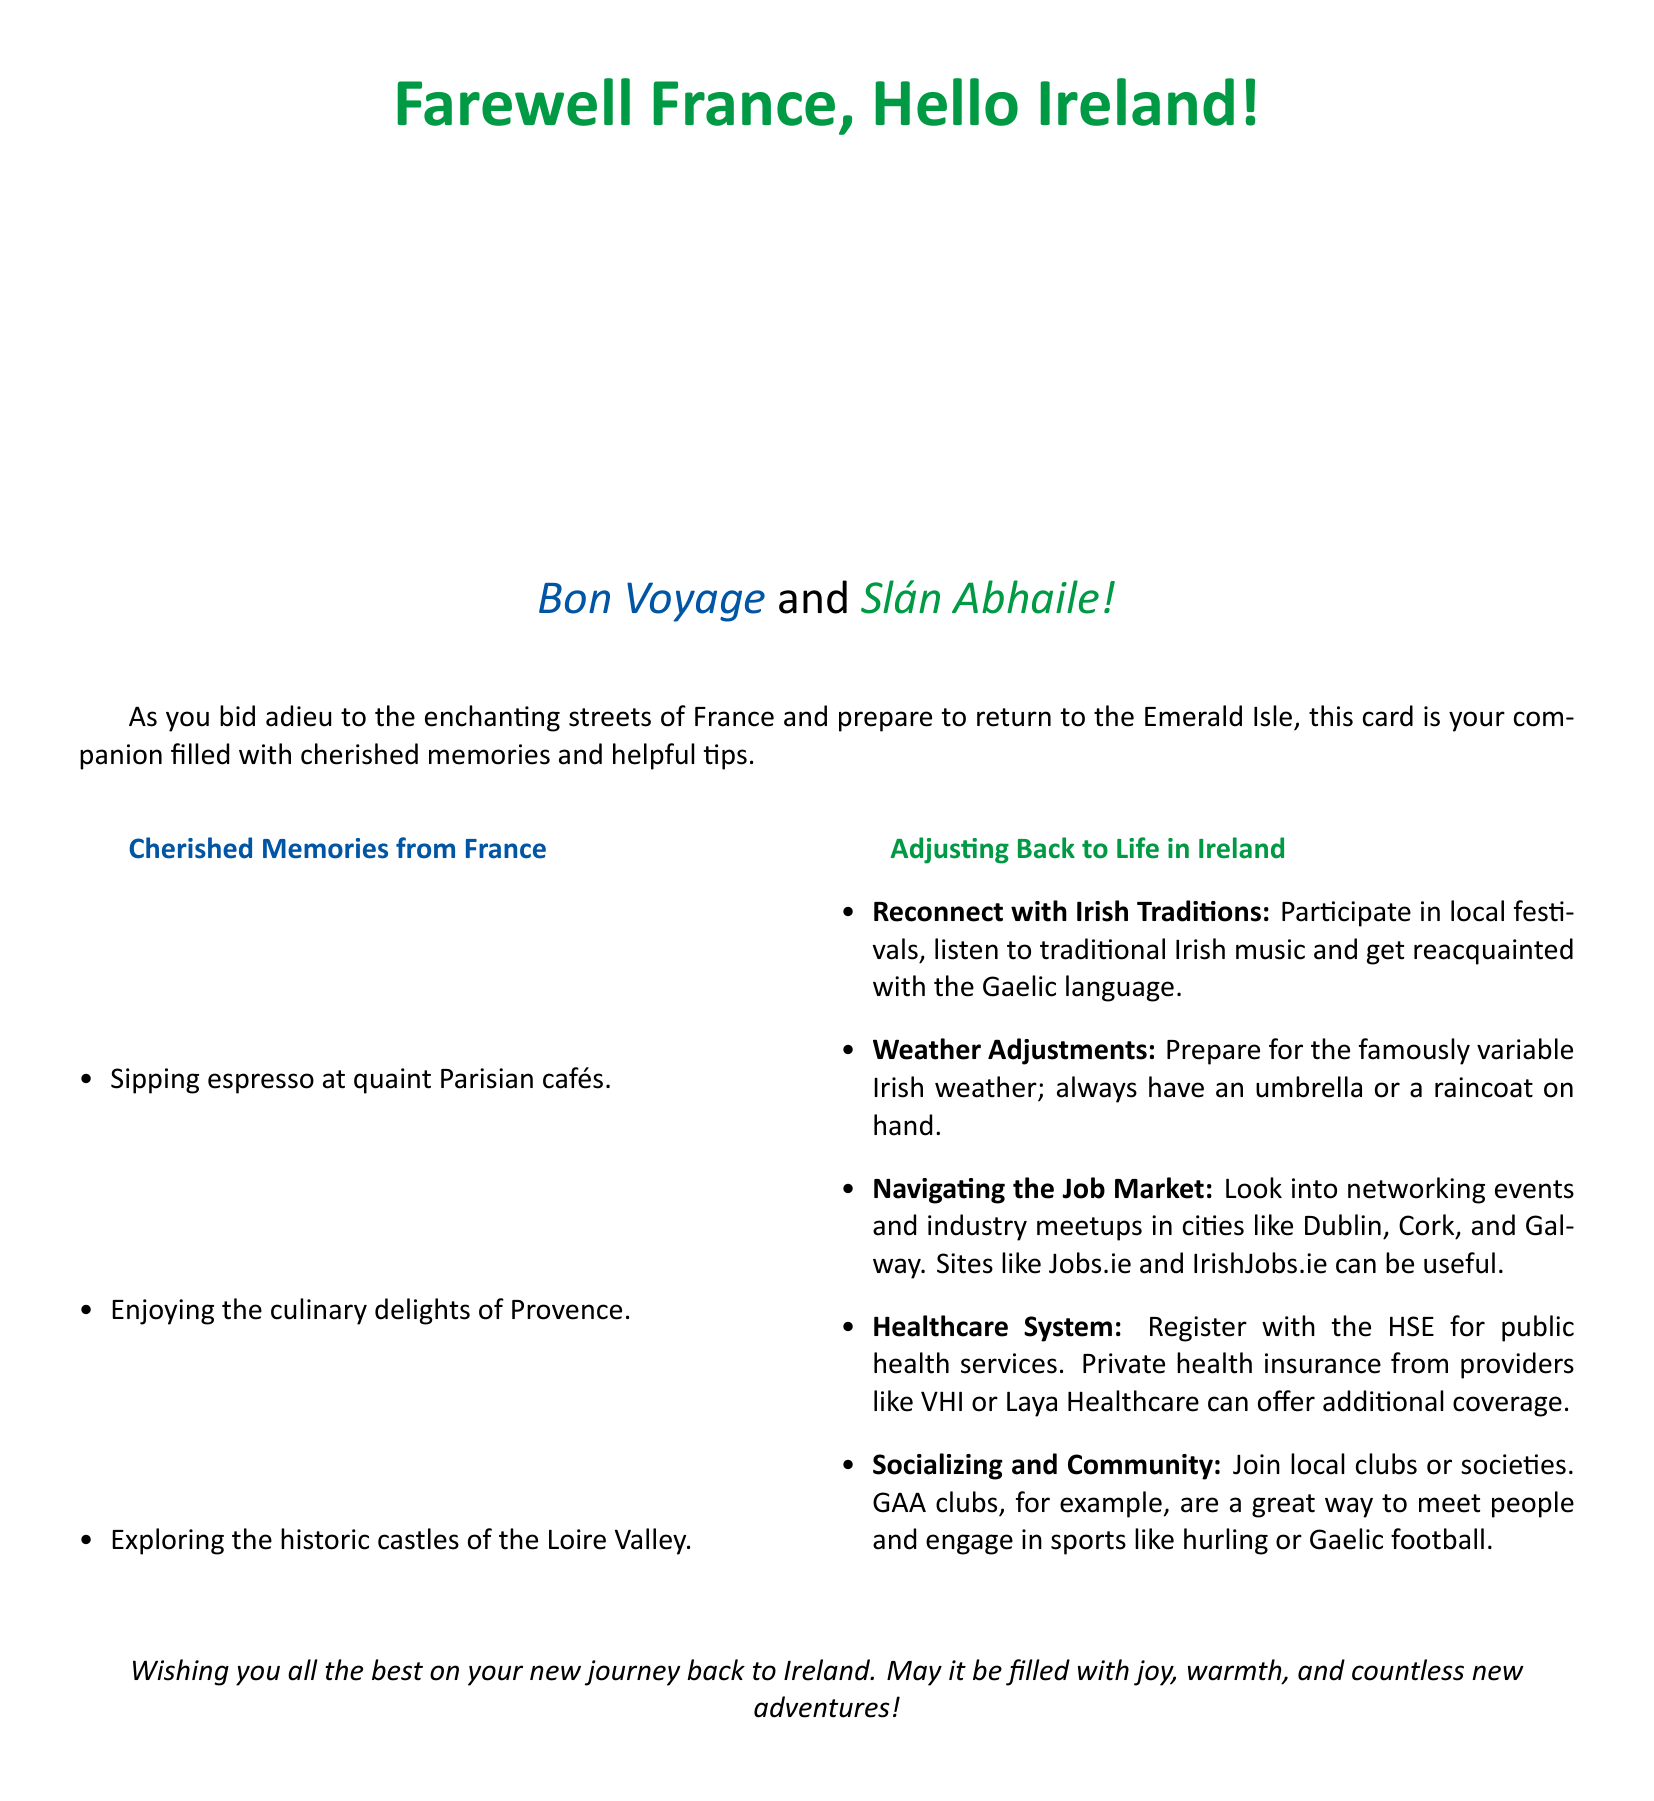What is the title of the card? The title of the card is highlighted at the top of the document, welcoming the reader.
Answer: Farewell France, Hello Ireland! What are the two landmarks depicted? The card shows famous landmarks from France and Ireland, specified in the visuals.
Answer: La Tour Eiffel, Cliffs of Moher Which color represents France in the imagery? The document uses color coding to differentiate between French and Irish themes.
Answer: French blue What is a tip for adjusting to life in Ireland regarding traditions? One of the tips listed in the document suggests engaging with the local culture.
Answer: Reconnect with Irish Traditions How can you prepare for the Irish weather? One item under adjusting back to life in Ireland advises on practical preparations for the climate.
Answer: Have an umbrella or raincoat What type of clubs can help in socializing in Ireland? The card includes suggestions for community engagement and social opportunities.
Answer: GAA clubs What is the significance of the phrases “Bon Voyage” and “Slán Abhaile”? These phrases are notable as they represent farewell and welcome in their respective languages.
Answer: Farewell and Welcome How many cherished memories from France are listed in the document? The document contains a specific number of memory items focused on experiences in France.
Answer: Three 